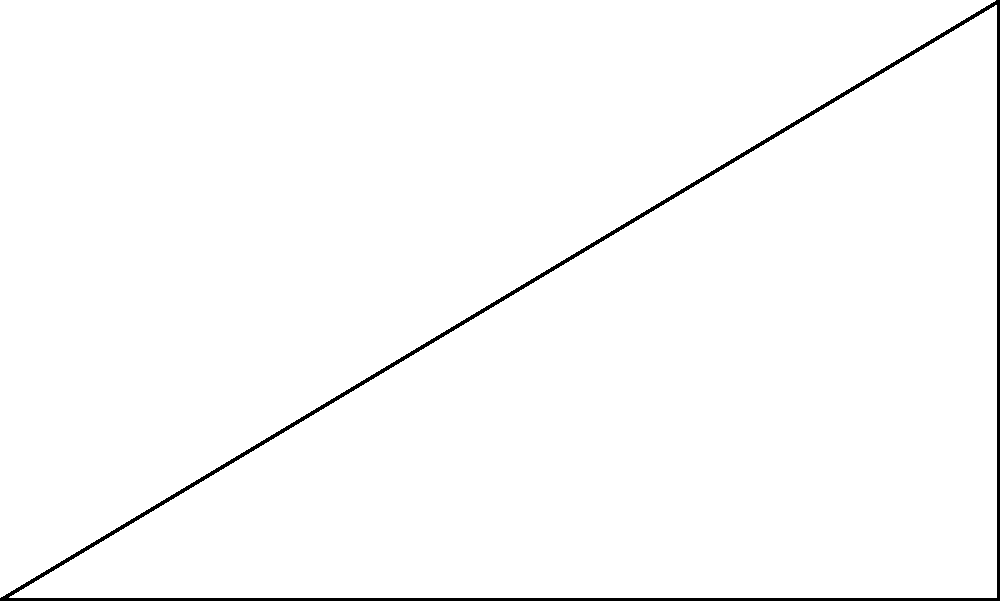In the designated fetch area of the dog park, a ball is thrown from point O and lands at point A, reaching a maximum height of 3 meters at point B. If the horizontal distance from O to A is 5 meters, what is the angle of trajectory ($\theta$) in degrees? To solve this problem, we'll use trigonometry:

1) The trajectory forms a right triangle with:
   - Base (adjacent side) = 5 meters
   - Height (opposite side) = 3 meters

2) We need to find the angle $\theta$ using the tangent function:

   $\tan(\theta) = \frac{\text{opposite}}{\text{adjacent}} = \frac{\text{height}}{\text{base}}$

3) Substituting the values:

   $\tan(\theta) = \frac{3}{5}$

4) To find $\theta$, we need to use the inverse tangent (arctan) function:

   $\theta = \arctan(\frac{3}{5})$

5) Using a calculator or trigonometric tables:

   $\theta \approx 30.96^\circ$

6) Rounding to the nearest degree:

   $\theta \approx 31^\circ$
Answer: $31^\circ$ 